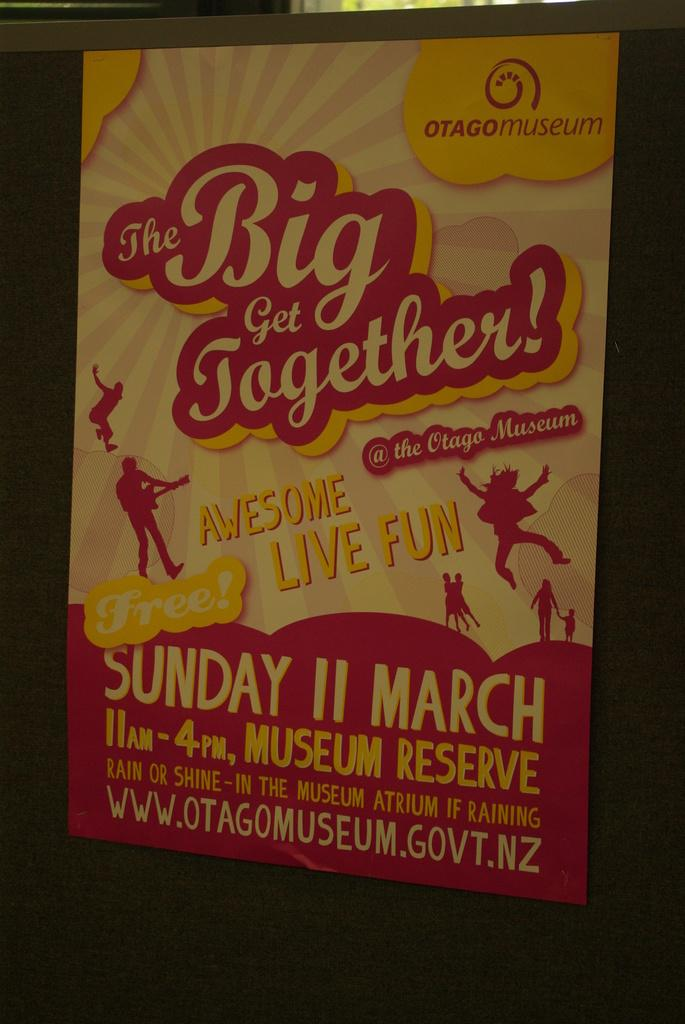What is present in the image that contains both text and images? There is a poster in the image that contains text and images. Can you describe the content of the poster? The poster contains text and images, but the specific content cannot be determined from the provided facts. How does the rain affect the poster in the image? There is no rain present in the image, so it cannot affect the poster. What type of rod is used to hold the poster in the image? There is no rod mentioned or visible in the image. 